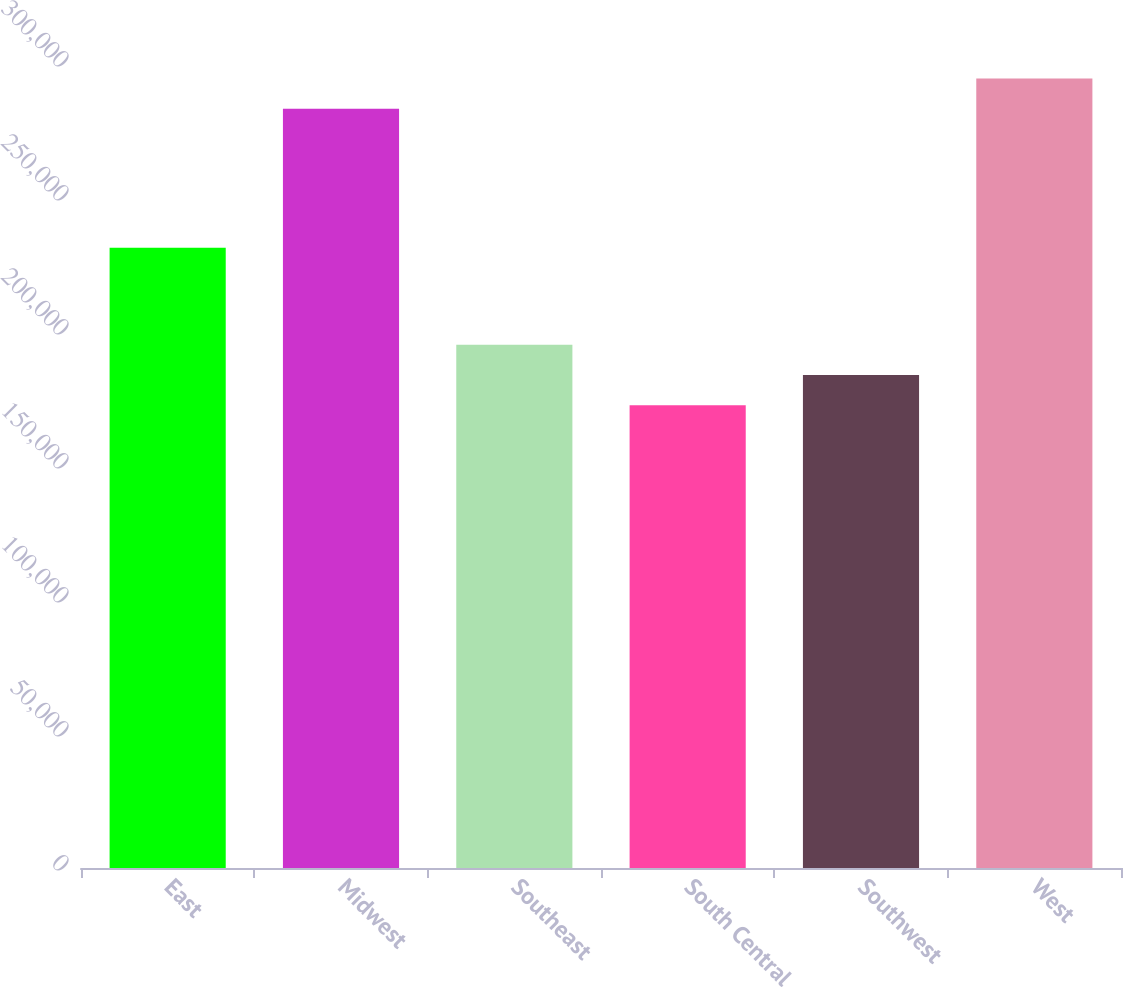<chart> <loc_0><loc_0><loc_500><loc_500><bar_chart><fcel>East<fcel>Midwest<fcel>Southeast<fcel>South Central<fcel>Southwest<fcel>West<nl><fcel>231400<fcel>283300<fcel>195280<fcel>172700<fcel>183990<fcel>294590<nl></chart> 